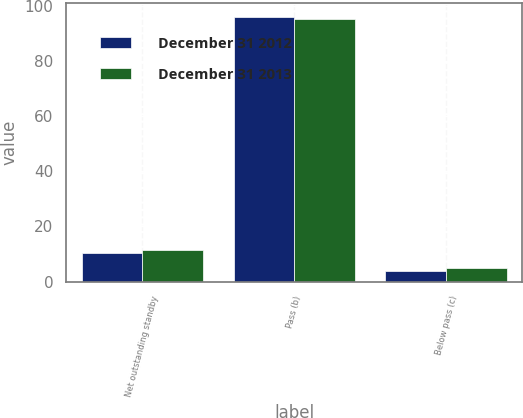Convert chart to OTSL. <chart><loc_0><loc_0><loc_500><loc_500><stacked_bar_chart><ecel><fcel>Net outstanding standby<fcel>Pass (b)<fcel>Below pass (c)<nl><fcel>December 31 2012<fcel>10.5<fcel>96<fcel>4<nl><fcel>December 31 2013<fcel>11.5<fcel>95<fcel>5<nl></chart> 